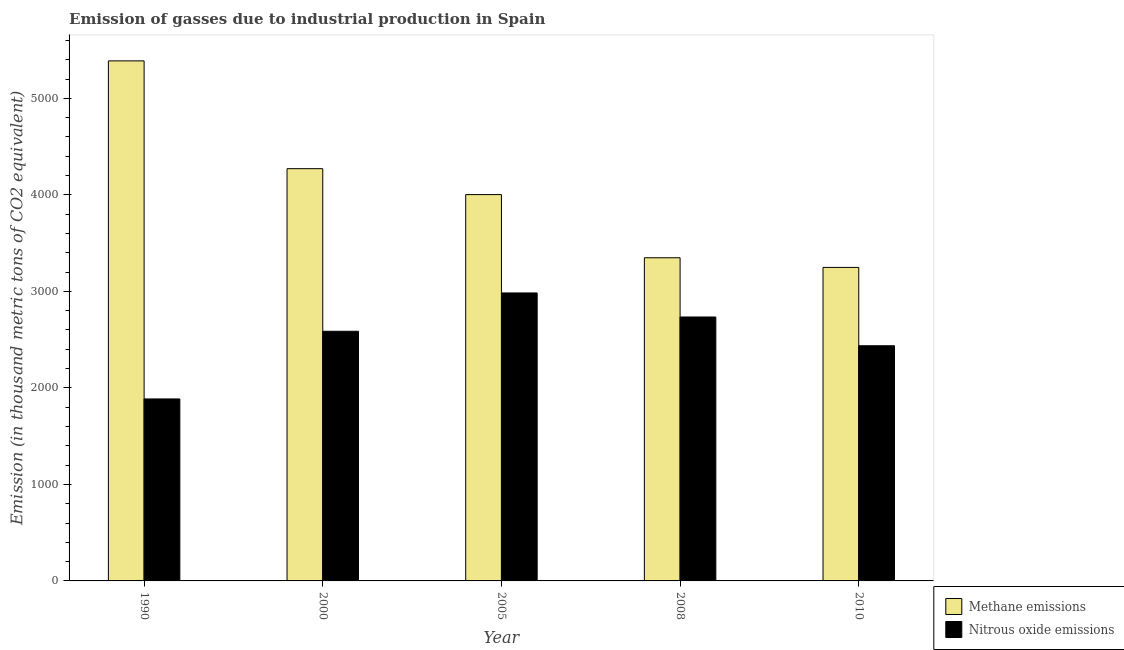How many bars are there on the 4th tick from the left?
Make the answer very short. 2. In how many cases, is the number of bars for a given year not equal to the number of legend labels?
Offer a very short reply. 0. What is the amount of nitrous oxide emissions in 2005?
Provide a succinct answer. 2983.4. Across all years, what is the maximum amount of methane emissions?
Your answer should be very brief. 5387.8. Across all years, what is the minimum amount of nitrous oxide emissions?
Offer a very short reply. 1885.3. In which year was the amount of methane emissions maximum?
Make the answer very short. 1990. What is the total amount of methane emissions in the graph?
Offer a very short reply. 2.03e+04. What is the difference between the amount of methane emissions in 2000 and that in 2010?
Keep it short and to the point. 1022.9. What is the difference between the amount of nitrous oxide emissions in 2000 and the amount of methane emissions in 2005?
Give a very brief answer. -396.9. What is the average amount of nitrous oxide emissions per year?
Ensure brevity in your answer.  2525.2. What is the ratio of the amount of methane emissions in 1990 to that in 2005?
Keep it short and to the point. 1.35. Is the difference between the amount of methane emissions in 1990 and 2005 greater than the difference between the amount of nitrous oxide emissions in 1990 and 2005?
Provide a succinct answer. No. What is the difference between the highest and the second highest amount of methane emissions?
Your response must be concise. 1116.8. What is the difference between the highest and the lowest amount of nitrous oxide emissions?
Provide a succinct answer. 1098.1. What does the 2nd bar from the left in 1990 represents?
Your answer should be very brief. Nitrous oxide emissions. What does the 1st bar from the right in 2010 represents?
Ensure brevity in your answer.  Nitrous oxide emissions. Are the values on the major ticks of Y-axis written in scientific E-notation?
Provide a short and direct response. No. Does the graph contain any zero values?
Your response must be concise. No. What is the title of the graph?
Offer a terse response. Emission of gasses due to industrial production in Spain. What is the label or title of the Y-axis?
Offer a very short reply. Emission (in thousand metric tons of CO2 equivalent). What is the Emission (in thousand metric tons of CO2 equivalent) of Methane emissions in 1990?
Your answer should be compact. 5387.8. What is the Emission (in thousand metric tons of CO2 equivalent) of Nitrous oxide emissions in 1990?
Give a very brief answer. 1885.3. What is the Emission (in thousand metric tons of CO2 equivalent) of Methane emissions in 2000?
Your response must be concise. 4271. What is the Emission (in thousand metric tons of CO2 equivalent) of Nitrous oxide emissions in 2000?
Your response must be concise. 2586.5. What is the Emission (in thousand metric tons of CO2 equivalent) in Methane emissions in 2005?
Offer a terse response. 4002.6. What is the Emission (in thousand metric tons of CO2 equivalent) of Nitrous oxide emissions in 2005?
Ensure brevity in your answer.  2983.4. What is the Emission (in thousand metric tons of CO2 equivalent) of Methane emissions in 2008?
Ensure brevity in your answer.  3348.1. What is the Emission (in thousand metric tons of CO2 equivalent) of Nitrous oxide emissions in 2008?
Give a very brief answer. 2734.4. What is the Emission (in thousand metric tons of CO2 equivalent) of Methane emissions in 2010?
Offer a very short reply. 3248.1. What is the Emission (in thousand metric tons of CO2 equivalent) of Nitrous oxide emissions in 2010?
Ensure brevity in your answer.  2436.4. Across all years, what is the maximum Emission (in thousand metric tons of CO2 equivalent) of Methane emissions?
Offer a terse response. 5387.8. Across all years, what is the maximum Emission (in thousand metric tons of CO2 equivalent) in Nitrous oxide emissions?
Your answer should be very brief. 2983.4. Across all years, what is the minimum Emission (in thousand metric tons of CO2 equivalent) of Methane emissions?
Offer a terse response. 3248.1. Across all years, what is the minimum Emission (in thousand metric tons of CO2 equivalent) in Nitrous oxide emissions?
Give a very brief answer. 1885.3. What is the total Emission (in thousand metric tons of CO2 equivalent) in Methane emissions in the graph?
Offer a very short reply. 2.03e+04. What is the total Emission (in thousand metric tons of CO2 equivalent) of Nitrous oxide emissions in the graph?
Keep it short and to the point. 1.26e+04. What is the difference between the Emission (in thousand metric tons of CO2 equivalent) in Methane emissions in 1990 and that in 2000?
Provide a short and direct response. 1116.8. What is the difference between the Emission (in thousand metric tons of CO2 equivalent) in Nitrous oxide emissions in 1990 and that in 2000?
Give a very brief answer. -701.2. What is the difference between the Emission (in thousand metric tons of CO2 equivalent) in Methane emissions in 1990 and that in 2005?
Provide a short and direct response. 1385.2. What is the difference between the Emission (in thousand metric tons of CO2 equivalent) in Nitrous oxide emissions in 1990 and that in 2005?
Your answer should be compact. -1098.1. What is the difference between the Emission (in thousand metric tons of CO2 equivalent) of Methane emissions in 1990 and that in 2008?
Your response must be concise. 2039.7. What is the difference between the Emission (in thousand metric tons of CO2 equivalent) of Nitrous oxide emissions in 1990 and that in 2008?
Your response must be concise. -849.1. What is the difference between the Emission (in thousand metric tons of CO2 equivalent) in Methane emissions in 1990 and that in 2010?
Ensure brevity in your answer.  2139.7. What is the difference between the Emission (in thousand metric tons of CO2 equivalent) in Nitrous oxide emissions in 1990 and that in 2010?
Offer a terse response. -551.1. What is the difference between the Emission (in thousand metric tons of CO2 equivalent) of Methane emissions in 2000 and that in 2005?
Make the answer very short. 268.4. What is the difference between the Emission (in thousand metric tons of CO2 equivalent) of Nitrous oxide emissions in 2000 and that in 2005?
Keep it short and to the point. -396.9. What is the difference between the Emission (in thousand metric tons of CO2 equivalent) in Methane emissions in 2000 and that in 2008?
Offer a very short reply. 922.9. What is the difference between the Emission (in thousand metric tons of CO2 equivalent) in Nitrous oxide emissions in 2000 and that in 2008?
Make the answer very short. -147.9. What is the difference between the Emission (in thousand metric tons of CO2 equivalent) in Methane emissions in 2000 and that in 2010?
Offer a terse response. 1022.9. What is the difference between the Emission (in thousand metric tons of CO2 equivalent) in Nitrous oxide emissions in 2000 and that in 2010?
Keep it short and to the point. 150.1. What is the difference between the Emission (in thousand metric tons of CO2 equivalent) in Methane emissions in 2005 and that in 2008?
Provide a succinct answer. 654.5. What is the difference between the Emission (in thousand metric tons of CO2 equivalent) of Nitrous oxide emissions in 2005 and that in 2008?
Your response must be concise. 249. What is the difference between the Emission (in thousand metric tons of CO2 equivalent) of Methane emissions in 2005 and that in 2010?
Offer a terse response. 754.5. What is the difference between the Emission (in thousand metric tons of CO2 equivalent) of Nitrous oxide emissions in 2005 and that in 2010?
Give a very brief answer. 547. What is the difference between the Emission (in thousand metric tons of CO2 equivalent) of Methane emissions in 2008 and that in 2010?
Your answer should be compact. 100. What is the difference between the Emission (in thousand metric tons of CO2 equivalent) of Nitrous oxide emissions in 2008 and that in 2010?
Give a very brief answer. 298. What is the difference between the Emission (in thousand metric tons of CO2 equivalent) of Methane emissions in 1990 and the Emission (in thousand metric tons of CO2 equivalent) of Nitrous oxide emissions in 2000?
Ensure brevity in your answer.  2801.3. What is the difference between the Emission (in thousand metric tons of CO2 equivalent) of Methane emissions in 1990 and the Emission (in thousand metric tons of CO2 equivalent) of Nitrous oxide emissions in 2005?
Your answer should be compact. 2404.4. What is the difference between the Emission (in thousand metric tons of CO2 equivalent) in Methane emissions in 1990 and the Emission (in thousand metric tons of CO2 equivalent) in Nitrous oxide emissions in 2008?
Offer a terse response. 2653.4. What is the difference between the Emission (in thousand metric tons of CO2 equivalent) in Methane emissions in 1990 and the Emission (in thousand metric tons of CO2 equivalent) in Nitrous oxide emissions in 2010?
Ensure brevity in your answer.  2951.4. What is the difference between the Emission (in thousand metric tons of CO2 equivalent) of Methane emissions in 2000 and the Emission (in thousand metric tons of CO2 equivalent) of Nitrous oxide emissions in 2005?
Keep it short and to the point. 1287.6. What is the difference between the Emission (in thousand metric tons of CO2 equivalent) in Methane emissions in 2000 and the Emission (in thousand metric tons of CO2 equivalent) in Nitrous oxide emissions in 2008?
Offer a very short reply. 1536.6. What is the difference between the Emission (in thousand metric tons of CO2 equivalent) of Methane emissions in 2000 and the Emission (in thousand metric tons of CO2 equivalent) of Nitrous oxide emissions in 2010?
Provide a succinct answer. 1834.6. What is the difference between the Emission (in thousand metric tons of CO2 equivalent) in Methane emissions in 2005 and the Emission (in thousand metric tons of CO2 equivalent) in Nitrous oxide emissions in 2008?
Ensure brevity in your answer.  1268.2. What is the difference between the Emission (in thousand metric tons of CO2 equivalent) in Methane emissions in 2005 and the Emission (in thousand metric tons of CO2 equivalent) in Nitrous oxide emissions in 2010?
Offer a very short reply. 1566.2. What is the difference between the Emission (in thousand metric tons of CO2 equivalent) of Methane emissions in 2008 and the Emission (in thousand metric tons of CO2 equivalent) of Nitrous oxide emissions in 2010?
Your response must be concise. 911.7. What is the average Emission (in thousand metric tons of CO2 equivalent) of Methane emissions per year?
Your answer should be compact. 4051.52. What is the average Emission (in thousand metric tons of CO2 equivalent) of Nitrous oxide emissions per year?
Provide a short and direct response. 2525.2. In the year 1990, what is the difference between the Emission (in thousand metric tons of CO2 equivalent) of Methane emissions and Emission (in thousand metric tons of CO2 equivalent) of Nitrous oxide emissions?
Your answer should be compact. 3502.5. In the year 2000, what is the difference between the Emission (in thousand metric tons of CO2 equivalent) in Methane emissions and Emission (in thousand metric tons of CO2 equivalent) in Nitrous oxide emissions?
Give a very brief answer. 1684.5. In the year 2005, what is the difference between the Emission (in thousand metric tons of CO2 equivalent) in Methane emissions and Emission (in thousand metric tons of CO2 equivalent) in Nitrous oxide emissions?
Provide a succinct answer. 1019.2. In the year 2008, what is the difference between the Emission (in thousand metric tons of CO2 equivalent) of Methane emissions and Emission (in thousand metric tons of CO2 equivalent) of Nitrous oxide emissions?
Keep it short and to the point. 613.7. In the year 2010, what is the difference between the Emission (in thousand metric tons of CO2 equivalent) in Methane emissions and Emission (in thousand metric tons of CO2 equivalent) in Nitrous oxide emissions?
Give a very brief answer. 811.7. What is the ratio of the Emission (in thousand metric tons of CO2 equivalent) of Methane emissions in 1990 to that in 2000?
Provide a short and direct response. 1.26. What is the ratio of the Emission (in thousand metric tons of CO2 equivalent) in Nitrous oxide emissions in 1990 to that in 2000?
Your answer should be compact. 0.73. What is the ratio of the Emission (in thousand metric tons of CO2 equivalent) of Methane emissions in 1990 to that in 2005?
Your answer should be very brief. 1.35. What is the ratio of the Emission (in thousand metric tons of CO2 equivalent) in Nitrous oxide emissions in 1990 to that in 2005?
Keep it short and to the point. 0.63. What is the ratio of the Emission (in thousand metric tons of CO2 equivalent) of Methane emissions in 1990 to that in 2008?
Make the answer very short. 1.61. What is the ratio of the Emission (in thousand metric tons of CO2 equivalent) in Nitrous oxide emissions in 1990 to that in 2008?
Your answer should be compact. 0.69. What is the ratio of the Emission (in thousand metric tons of CO2 equivalent) of Methane emissions in 1990 to that in 2010?
Your answer should be very brief. 1.66. What is the ratio of the Emission (in thousand metric tons of CO2 equivalent) in Nitrous oxide emissions in 1990 to that in 2010?
Keep it short and to the point. 0.77. What is the ratio of the Emission (in thousand metric tons of CO2 equivalent) in Methane emissions in 2000 to that in 2005?
Provide a succinct answer. 1.07. What is the ratio of the Emission (in thousand metric tons of CO2 equivalent) in Nitrous oxide emissions in 2000 to that in 2005?
Ensure brevity in your answer.  0.87. What is the ratio of the Emission (in thousand metric tons of CO2 equivalent) in Methane emissions in 2000 to that in 2008?
Make the answer very short. 1.28. What is the ratio of the Emission (in thousand metric tons of CO2 equivalent) of Nitrous oxide emissions in 2000 to that in 2008?
Offer a very short reply. 0.95. What is the ratio of the Emission (in thousand metric tons of CO2 equivalent) in Methane emissions in 2000 to that in 2010?
Your response must be concise. 1.31. What is the ratio of the Emission (in thousand metric tons of CO2 equivalent) in Nitrous oxide emissions in 2000 to that in 2010?
Provide a succinct answer. 1.06. What is the ratio of the Emission (in thousand metric tons of CO2 equivalent) in Methane emissions in 2005 to that in 2008?
Make the answer very short. 1.2. What is the ratio of the Emission (in thousand metric tons of CO2 equivalent) of Nitrous oxide emissions in 2005 to that in 2008?
Provide a succinct answer. 1.09. What is the ratio of the Emission (in thousand metric tons of CO2 equivalent) in Methane emissions in 2005 to that in 2010?
Make the answer very short. 1.23. What is the ratio of the Emission (in thousand metric tons of CO2 equivalent) in Nitrous oxide emissions in 2005 to that in 2010?
Offer a very short reply. 1.22. What is the ratio of the Emission (in thousand metric tons of CO2 equivalent) of Methane emissions in 2008 to that in 2010?
Provide a short and direct response. 1.03. What is the ratio of the Emission (in thousand metric tons of CO2 equivalent) of Nitrous oxide emissions in 2008 to that in 2010?
Keep it short and to the point. 1.12. What is the difference between the highest and the second highest Emission (in thousand metric tons of CO2 equivalent) of Methane emissions?
Your response must be concise. 1116.8. What is the difference between the highest and the second highest Emission (in thousand metric tons of CO2 equivalent) in Nitrous oxide emissions?
Give a very brief answer. 249. What is the difference between the highest and the lowest Emission (in thousand metric tons of CO2 equivalent) of Methane emissions?
Your answer should be compact. 2139.7. What is the difference between the highest and the lowest Emission (in thousand metric tons of CO2 equivalent) in Nitrous oxide emissions?
Your response must be concise. 1098.1. 